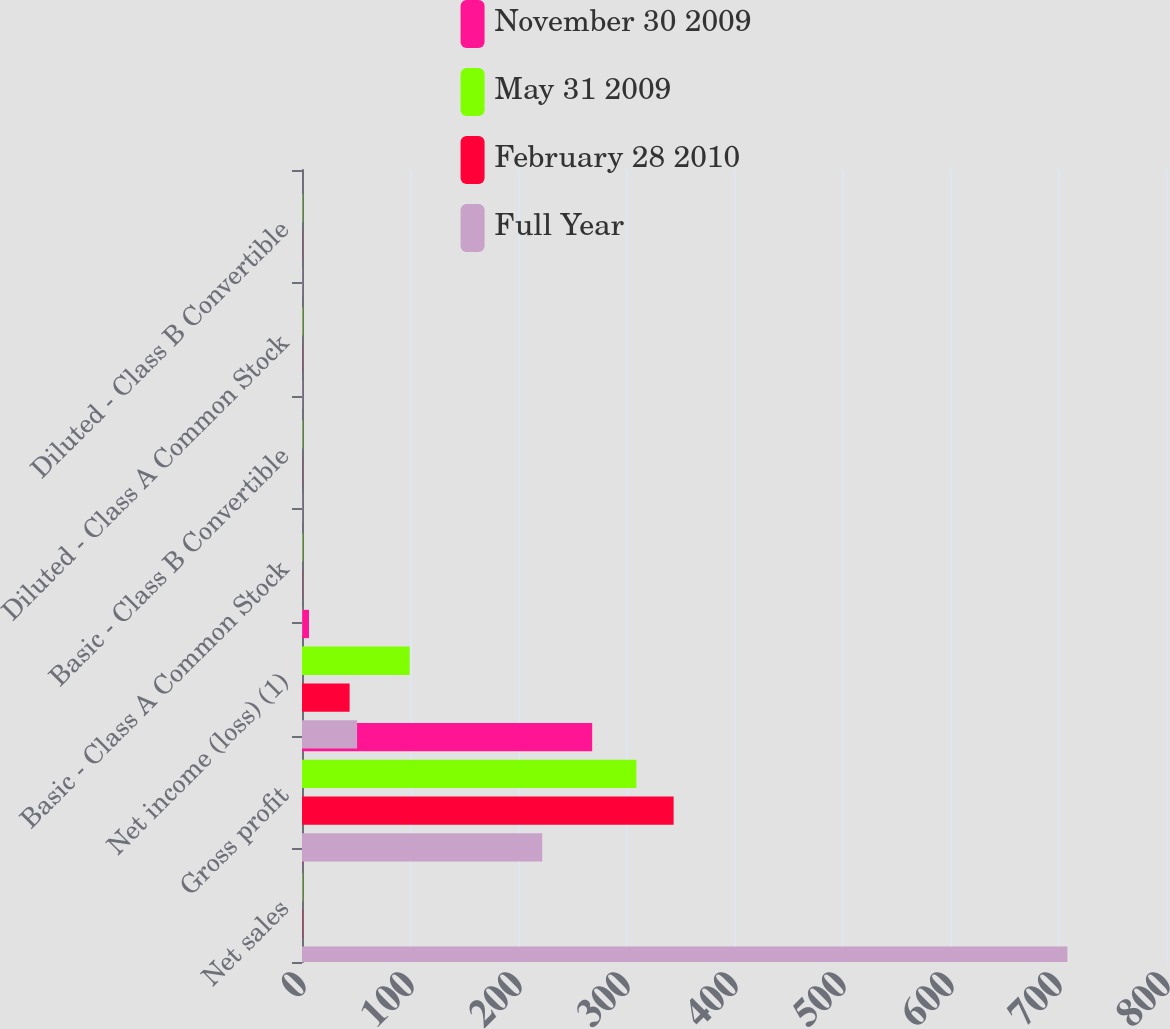Convert chart. <chart><loc_0><loc_0><loc_500><loc_500><stacked_bar_chart><ecel><fcel>Net sales<fcel>Gross profit<fcel>Net income (loss) (1)<fcel>Basic - Class A Common Stock<fcel>Basic - Class B Convertible<fcel>Diluted - Class A Common Stock<fcel>Diluted - Class B Convertible<nl><fcel>November 30 2009<fcel>0.41<fcel>268.7<fcel>6.5<fcel>0.03<fcel>0.03<fcel>0.03<fcel>0.03<nl><fcel>May 31 2009<fcel>0.41<fcel>309.6<fcel>99.7<fcel>0.46<fcel>0.42<fcel>0.45<fcel>0.41<nl><fcel>February 28 2010<fcel>0.41<fcel>344.1<fcel>44.1<fcel>0.2<fcel>0.18<fcel>0.2<fcel>0.18<nl><fcel>Full Year<fcel>708.7<fcel>222.4<fcel>51<fcel>0.23<fcel>0.21<fcel>0.23<fcel>0.21<nl></chart> 